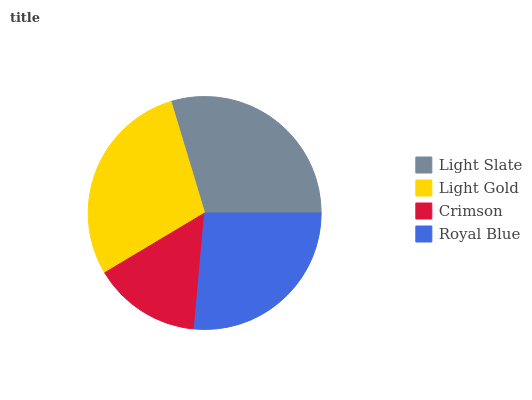Is Crimson the minimum?
Answer yes or no. Yes. Is Light Slate the maximum?
Answer yes or no. Yes. Is Light Gold the minimum?
Answer yes or no. No. Is Light Gold the maximum?
Answer yes or no. No. Is Light Slate greater than Light Gold?
Answer yes or no. Yes. Is Light Gold less than Light Slate?
Answer yes or no. Yes. Is Light Gold greater than Light Slate?
Answer yes or no. No. Is Light Slate less than Light Gold?
Answer yes or no. No. Is Light Gold the high median?
Answer yes or no. Yes. Is Royal Blue the low median?
Answer yes or no. Yes. Is Crimson the high median?
Answer yes or no. No. Is Crimson the low median?
Answer yes or no. No. 